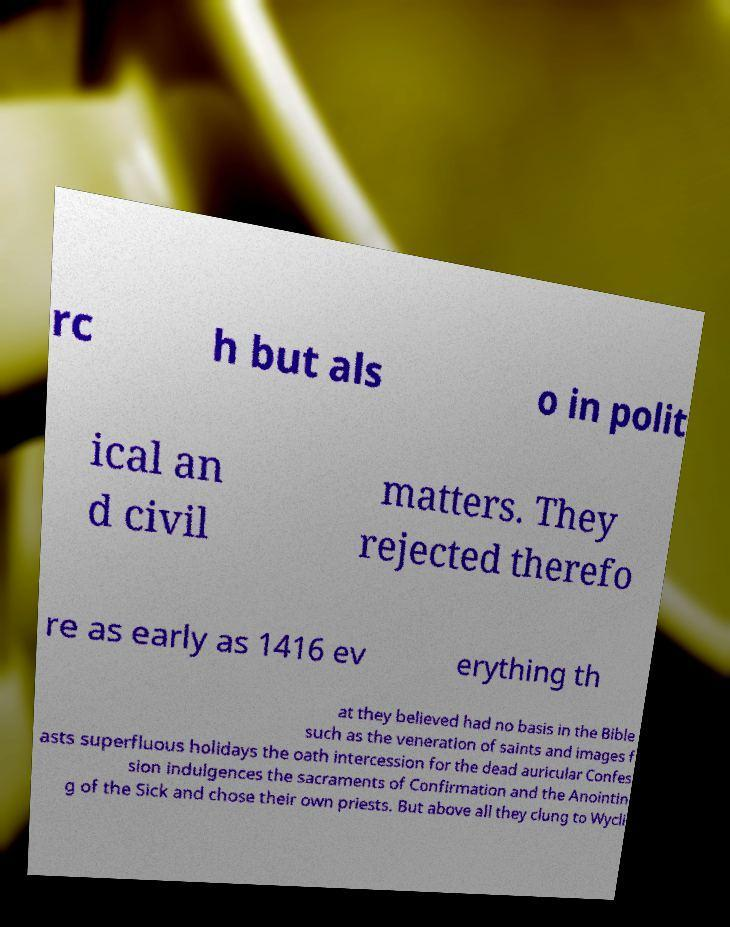For documentation purposes, I need the text within this image transcribed. Could you provide that? rc h but als o in polit ical an d civil matters. They rejected therefo re as early as 1416 ev erything th at they believed had no basis in the Bible such as the veneration of saints and images f asts superfluous holidays the oath intercession for the dead auricular Confes sion indulgences the sacraments of Confirmation and the Anointin g of the Sick and chose their own priests. But above all they clung to Wycli 